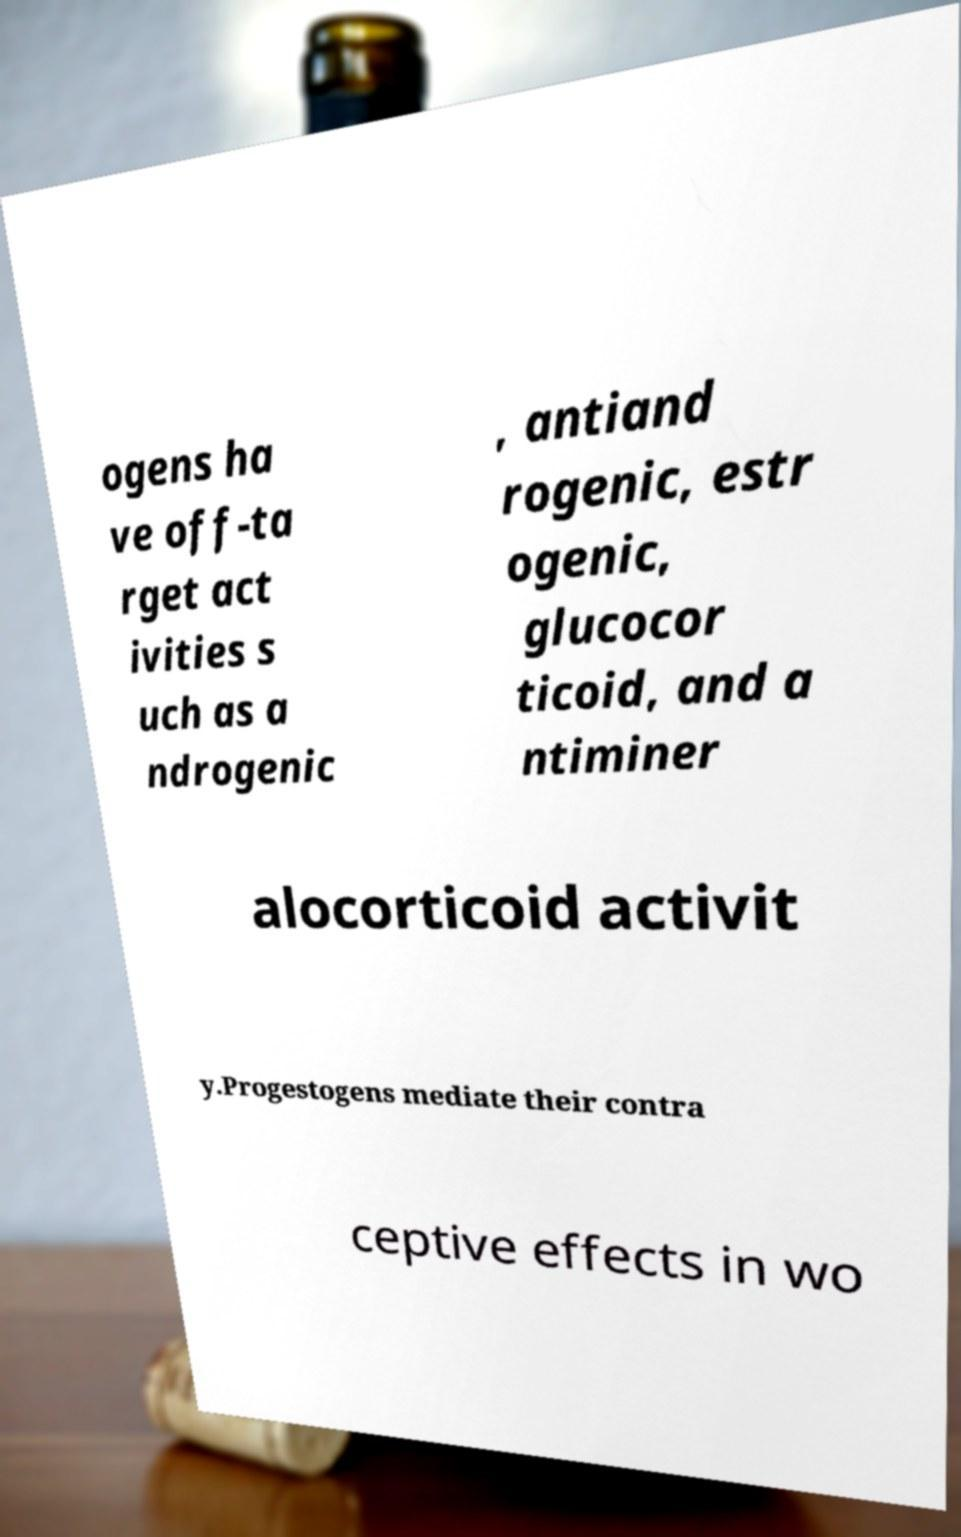There's text embedded in this image that I need extracted. Can you transcribe it verbatim? ogens ha ve off-ta rget act ivities s uch as a ndrogenic , antiand rogenic, estr ogenic, glucocor ticoid, and a ntiminer alocorticoid activit y.Progestogens mediate their contra ceptive effects in wo 